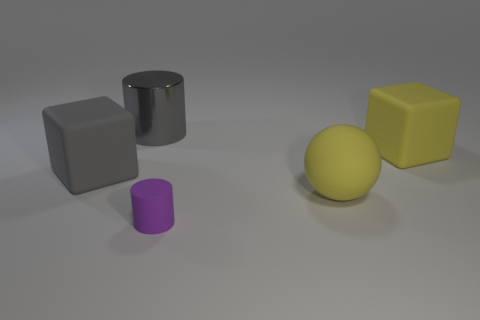Is there anything else that is made of the same material as the big gray cylinder?
Keep it short and to the point. No. There is a cube that is to the left of the yellow thing in front of the big rubber object left of the large cylinder; what is its color?
Your answer should be compact. Gray. How many large things are matte cubes or yellow spheres?
Provide a short and direct response. 3. Is the number of matte cylinders in front of the tiny cylinder the same as the number of red balls?
Your answer should be very brief. Yes. There is a gray metal object; are there any yellow blocks in front of it?
Offer a very short reply. Yes. What number of metallic things are either tiny purple things or big yellow balls?
Provide a succinct answer. 0. There is a big matte ball; how many small rubber cylinders are to the left of it?
Your answer should be compact. 1. Are there any matte blocks of the same size as the metallic thing?
Offer a terse response. Yes. Are there any big metal cylinders of the same color as the rubber sphere?
Your response must be concise. No. Is there any other thing that has the same size as the rubber cylinder?
Make the answer very short. No. 